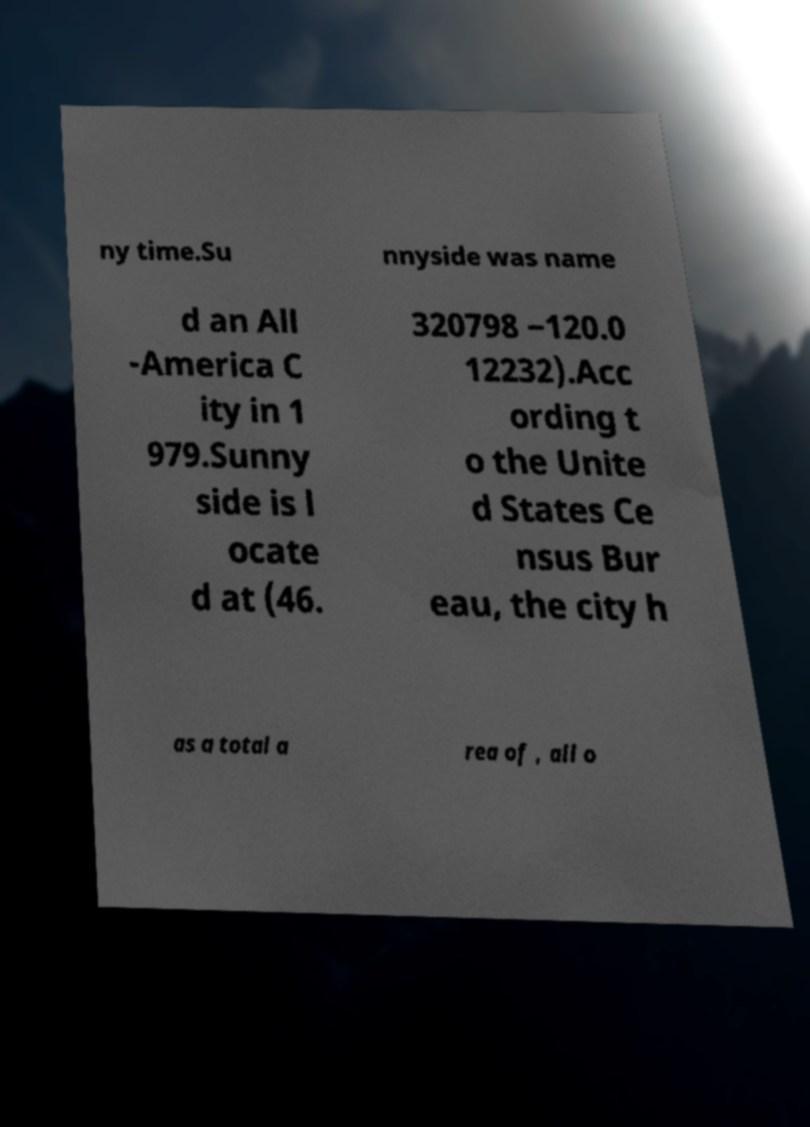Please identify and transcribe the text found in this image. ny time.Su nnyside was name d an All -America C ity in 1 979.Sunny side is l ocate d at (46. 320798 −120.0 12232).Acc ording t o the Unite d States Ce nsus Bur eau, the city h as a total a rea of , all o 